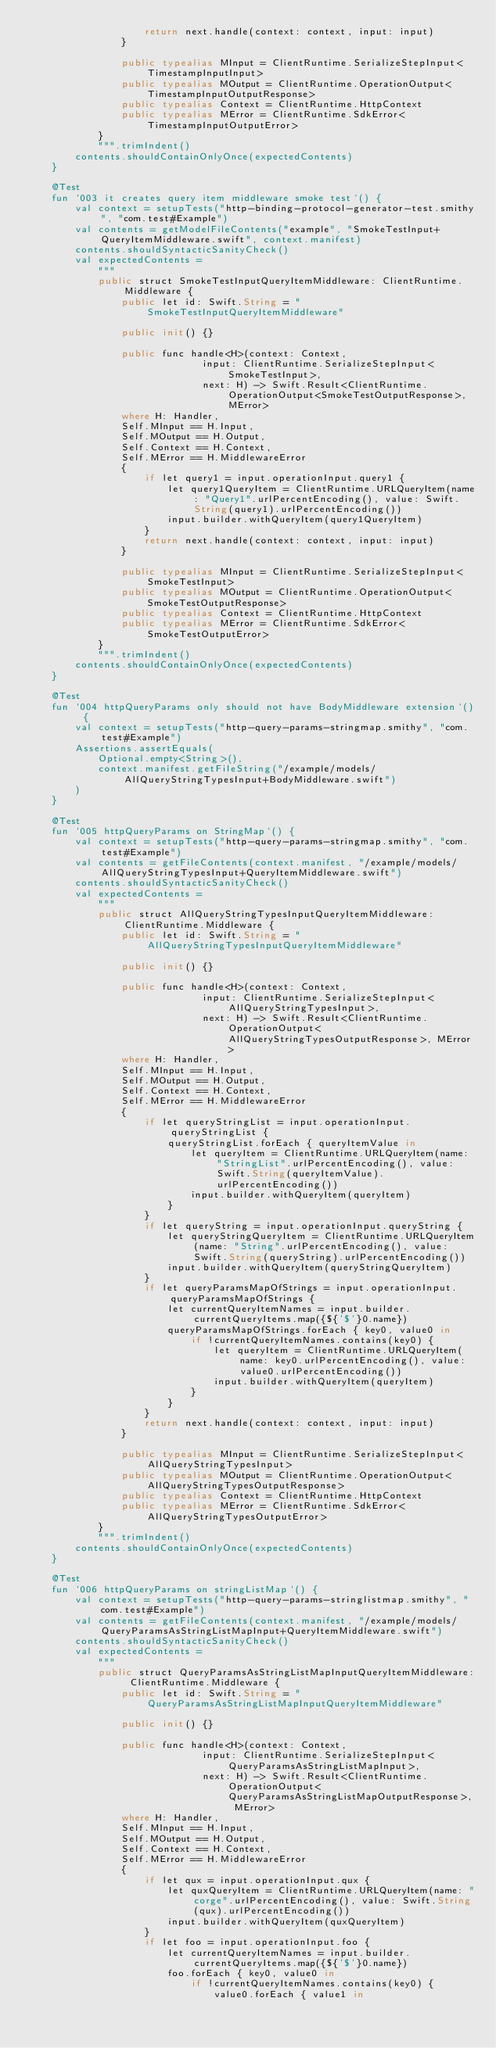Convert code to text. <code><loc_0><loc_0><loc_500><loc_500><_Kotlin_>                    return next.handle(context: context, input: input)
                }
            
                public typealias MInput = ClientRuntime.SerializeStepInput<TimestampInputInput>
                public typealias MOutput = ClientRuntime.OperationOutput<TimestampInputOutputResponse>
                public typealias Context = ClientRuntime.HttpContext
                public typealias MError = ClientRuntime.SdkError<TimestampInputOutputError>
            }
            """.trimIndent()
        contents.shouldContainOnlyOnce(expectedContents)
    }

    @Test
    fun `003 it creates query item middleware smoke test`() {
        val context = setupTests("http-binding-protocol-generator-test.smithy", "com.test#Example")
        val contents = getModelFileContents("example", "SmokeTestInput+QueryItemMiddleware.swift", context.manifest)
        contents.shouldSyntacticSanityCheck()
        val expectedContents =
            """
            public struct SmokeTestInputQueryItemMiddleware: ClientRuntime.Middleware {
                public let id: Swift.String = "SmokeTestInputQueryItemMiddleware"
            
                public init() {}
            
                public func handle<H>(context: Context,
                              input: ClientRuntime.SerializeStepInput<SmokeTestInput>,
                              next: H) -> Swift.Result<ClientRuntime.OperationOutput<SmokeTestOutputResponse>, MError>
                where H: Handler,
                Self.MInput == H.Input,
                Self.MOutput == H.Output,
                Self.Context == H.Context,
                Self.MError == H.MiddlewareError
                {
                    if let query1 = input.operationInput.query1 {
                        let query1QueryItem = ClientRuntime.URLQueryItem(name: "Query1".urlPercentEncoding(), value: Swift.String(query1).urlPercentEncoding())
                        input.builder.withQueryItem(query1QueryItem)
                    }
                    return next.handle(context: context, input: input)
                }
            
                public typealias MInput = ClientRuntime.SerializeStepInput<SmokeTestInput>
                public typealias MOutput = ClientRuntime.OperationOutput<SmokeTestOutputResponse>
                public typealias Context = ClientRuntime.HttpContext
                public typealias MError = ClientRuntime.SdkError<SmokeTestOutputError>
            }
            """.trimIndent()
        contents.shouldContainOnlyOnce(expectedContents)
    }

    @Test
    fun `004 httpQueryParams only should not have BodyMiddleware extension`() {
        val context = setupTests("http-query-params-stringmap.smithy", "com.test#Example")
        Assertions.assertEquals(
            Optional.empty<String>(),
            context.manifest.getFileString("/example/models/AllQueryStringTypesInput+BodyMiddleware.swift")
        )
    }

    @Test
    fun `005 httpQueryParams on StringMap`() {
        val context = setupTests("http-query-params-stringmap.smithy", "com.test#Example")
        val contents = getFileContents(context.manifest, "/example/models/AllQueryStringTypesInput+QueryItemMiddleware.swift")
        contents.shouldSyntacticSanityCheck()
        val expectedContents =
            """
            public struct AllQueryStringTypesInputQueryItemMiddleware: ClientRuntime.Middleware {
                public let id: Swift.String = "AllQueryStringTypesInputQueryItemMiddleware"
            
                public init() {}
            
                public func handle<H>(context: Context,
                              input: ClientRuntime.SerializeStepInput<AllQueryStringTypesInput>,
                              next: H) -> Swift.Result<ClientRuntime.OperationOutput<AllQueryStringTypesOutputResponse>, MError>
                where H: Handler,
                Self.MInput == H.Input,
                Self.MOutput == H.Output,
                Self.Context == H.Context,
                Self.MError == H.MiddlewareError
                {
                    if let queryStringList = input.operationInput.queryStringList {
                        queryStringList.forEach { queryItemValue in
                            let queryItem = ClientRuntime.URLQueryItem(name: "StringList".urlPercentEncoding(), value: Swift.String(queryItemValue).urlPercentEncoding())
                            input.builder.withQueryItem(queryItem)
                        }
                    }
                    if let queryString = input.operationInput.queryString {
                        let queryStringQueryItem = ClientRuntime.URLQueryItem(name: "String".urlPercentEncoding(), value: Swift.String(queryString).urlPercentEncoding())
                        input.builder.withQueryItem(queryStringQueryItem)
                    }
                    if let queryParamsMapOfStrings = input.operationInput.queryParamsMapOfStrings {
                        let currentQueryItemNames = input.builder.currentQueryItems.map({${'$'}0.name})
                        queryParamsMapOfStrings.forEach { key0, value0 in
                            if !currentQueryItemNames.contains(key0) {
                                let queryItem = ClientRuntime.URLQueryItem(name: key0.urlPercentEncoding(), value: value0.urlPercentEncoding())
                                input.builder.withQueryItem(queryItem)
                            }
                        }
                    }
                    return next.handle(context: context, input: input)
                }
            
                public typealias MInput = ClientRuntime.SerializeStepInput<AllQueryStringTypesInput>
                public typealias MOutput = ClientRuntime.OperationOutput<AllQueryStringTypesOutputResponse>
                public typealias Context = ClientRuntime.HttpContext
                public typealias MError = ClientRuntime.SdkError<AllQueryStringTypesOutputError>
            }
            """.trimIndent()
        contents.shouldContainOnlyOnce(expectedContents)
    }

    @Test
    fun `006 httpQueryParams on stringListMap`() {
        val context = setupTests("http-query-params-stringlistmap.smithy", "com.test#Example")
        val contents = getFileContents(context.manifest, "/example/models/QueryParamsAsStringListMapInput+QueryItemMiddleware.swift")
        contents.shouldSyntacticSanityCheck()
        val expectedContents =
            """
            public struct QueryParamsAsStringListMapInputQueryItemMiddleware: ClientRuntime.Middleware {
                public let id: Swift.String = "QueryParamsAsStringListMapInputQueryItemMiddleware"
            
                public init() {}
            
                public func handle<H>(context: Context,
                              input: ClientRuntime.SerializeStepInput<QueryParamsAsStringListMapInput>,
                              next: H) -> Swift.Result<ClientRuntime.OperationOutput<QueryParamsAsStringListMapOutputResponse>, MError>
                where H: Handler,
                Self.MInput == H.Input,
                Self.MOutput == H.Output,
                Self.Context == H.Context,
                Self.MError == H.MiddlewareError
                {
                    if let qux = input.operationInput.qux {
                        let quxQueryItem = ClientRuntime.URLQueryItem(name: "corge".urlPercentEncoding(), value: Swift.String(qux).urlPercentEncoding())
                        input.builder.withQueryItem(quxQueryItem)
                    }
                    if let foo = input.operationInput.foo {
                        let currentQueryItemNames = input.builder.currentQueryItems.map({${'$'}0.name})
                        foo.forEach { key0, value0 in
                            if !currentQueryItemNames.contains(key0) {
                                value0.forEach { value1 in</code> 